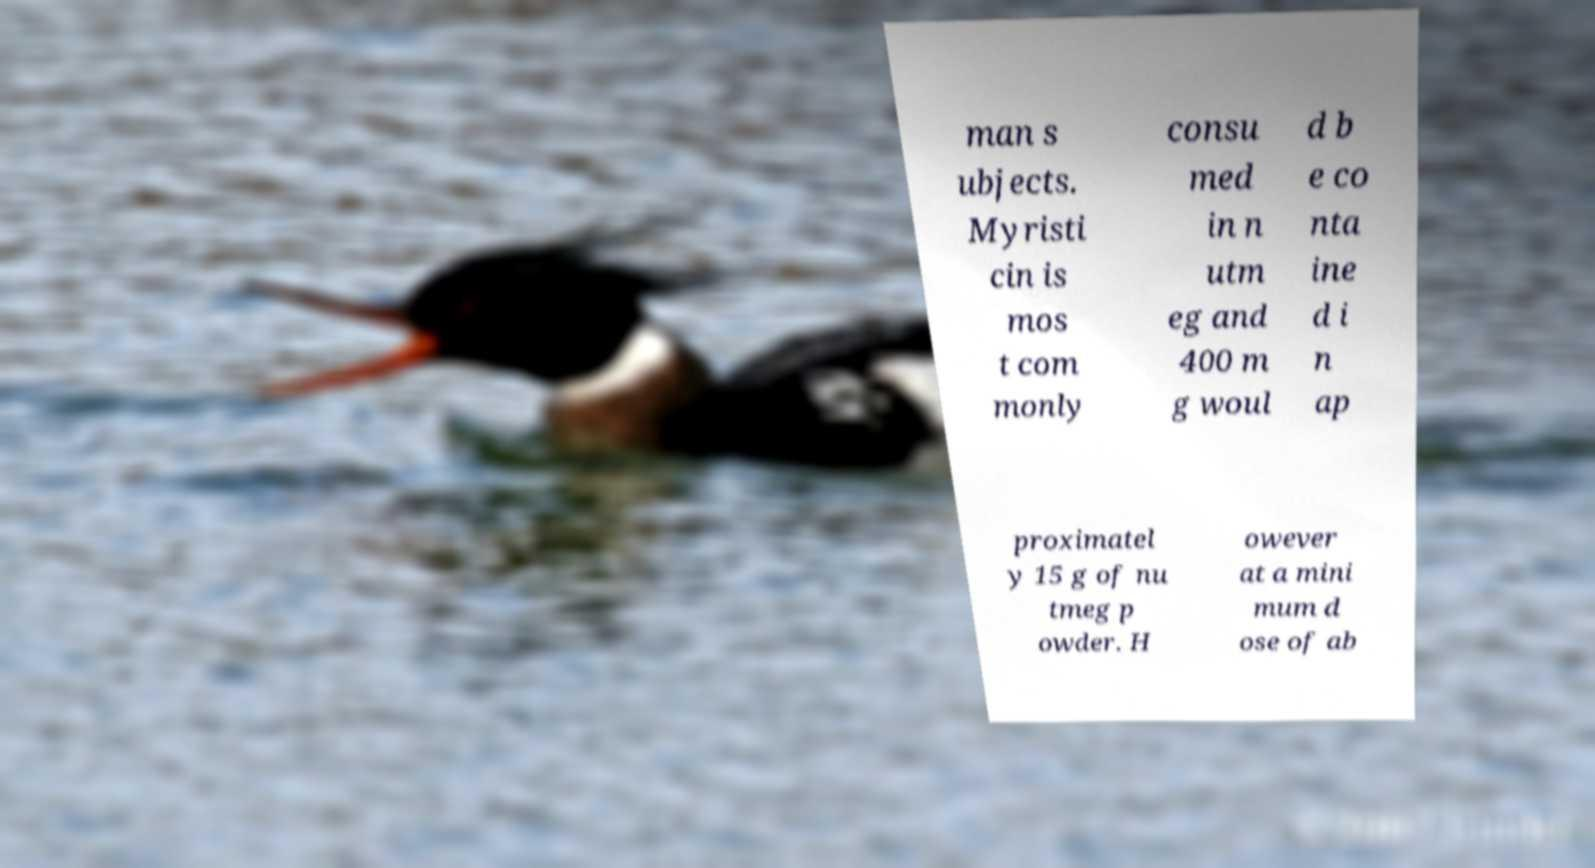What messages or text are displayed in this image? I need them in a readable, typed format. man s ubjects. Myristi cin is mos t com monly consu med in n utm eg and 400 m g woul d b e co nta ine d i n ap proximatel y 15 g of nu tmeg p owder. H owever at a mini mum d ose of ab 